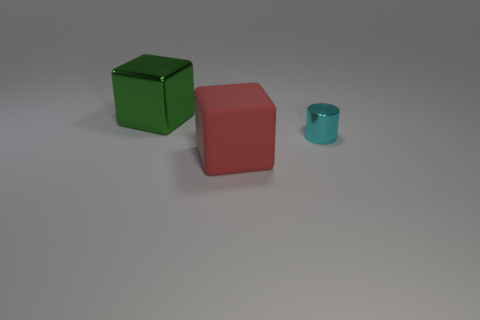Is there anything else that has the same size as the red matte thing?
Provide a succinct answer. Yes. Is the matte thing the same shape as the cyan object?
Offer a terse response. No. Is there any other thing that is the same shape as the green shiny object?
Make the answer very short. Yes. Is there a small yellow cylinder?
Your answer should be very brief. No. Do the cyan thing and the big thing in front of the small cyan thing have the same shape?
Keep it short and to the point. No. What material is the tiny cylinder that is to the right of the large object to the left of the big red cube?
Your answer should be compact. Metal. The tiny cylinder is what color?
Keep it short and to the point. Cyan. Is the color of the large block in front of the green metallic object the same as the thing behind the cyan metal cylinder?
Your response must be concise. No. What size is the other thing that is the same shape as the large matte thing?
Offer a very short reply. Large. Are there any metallic things that have the same color as the large shiny cube?
Give a very brief answer. No. 